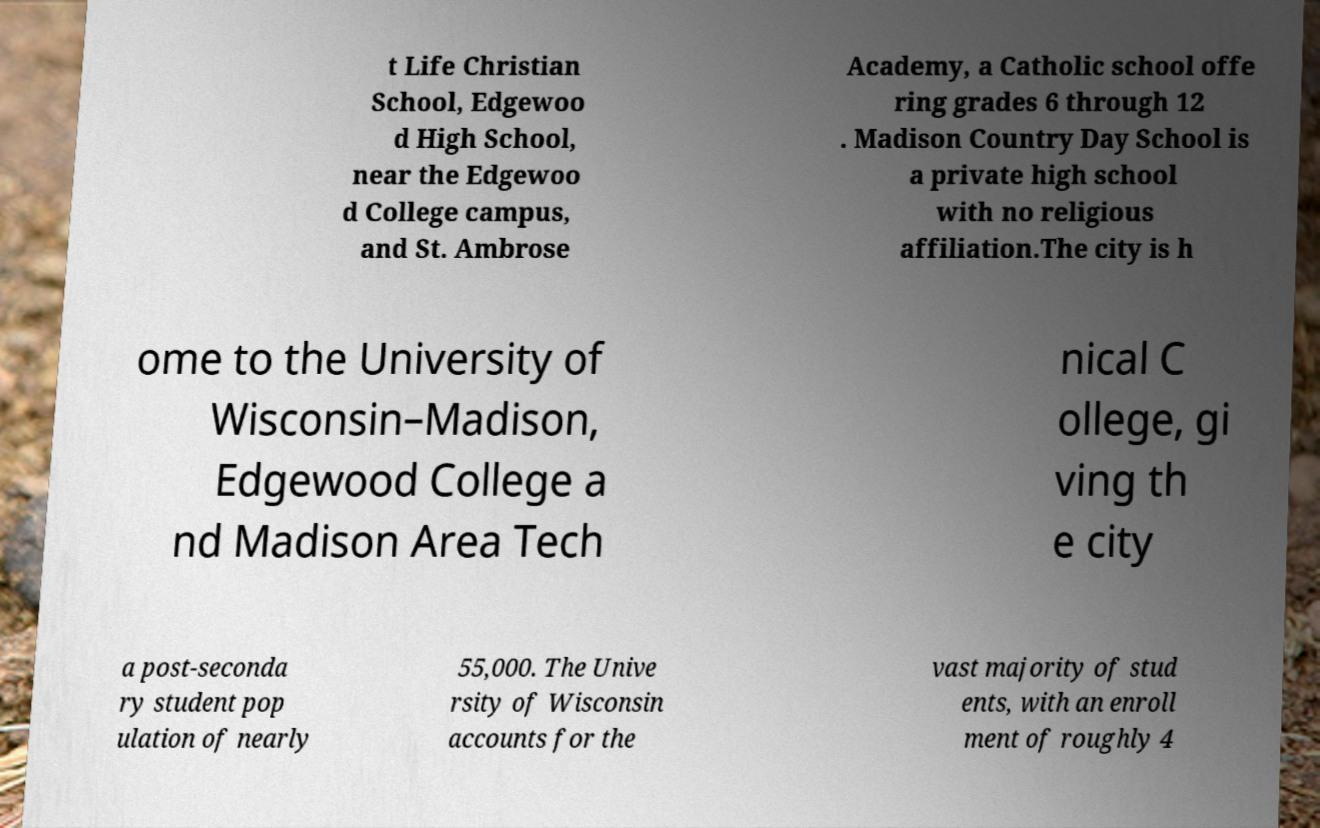What messages or text are displayed in this image? I need them in a readable, typed format. t Life Christian School, Edgewoo d High School, near the Edgewoo d College campus, and St. Ambrose Academy, a Catholic school offe ring grades 6 through 12 . Madison Country Day School is a private high school with no religious affiliation.The city is h ome to the University of Wisconsin–Madison, Edgewood College a nd Madison Area Tech nical C ollege, gi ving th e city a post-seconda ry student pop ulation of nearly 55,000. The Unive rsity of Wisconsin accounts for the vast majority of stud ents, with an enroll ment of roughly 4 